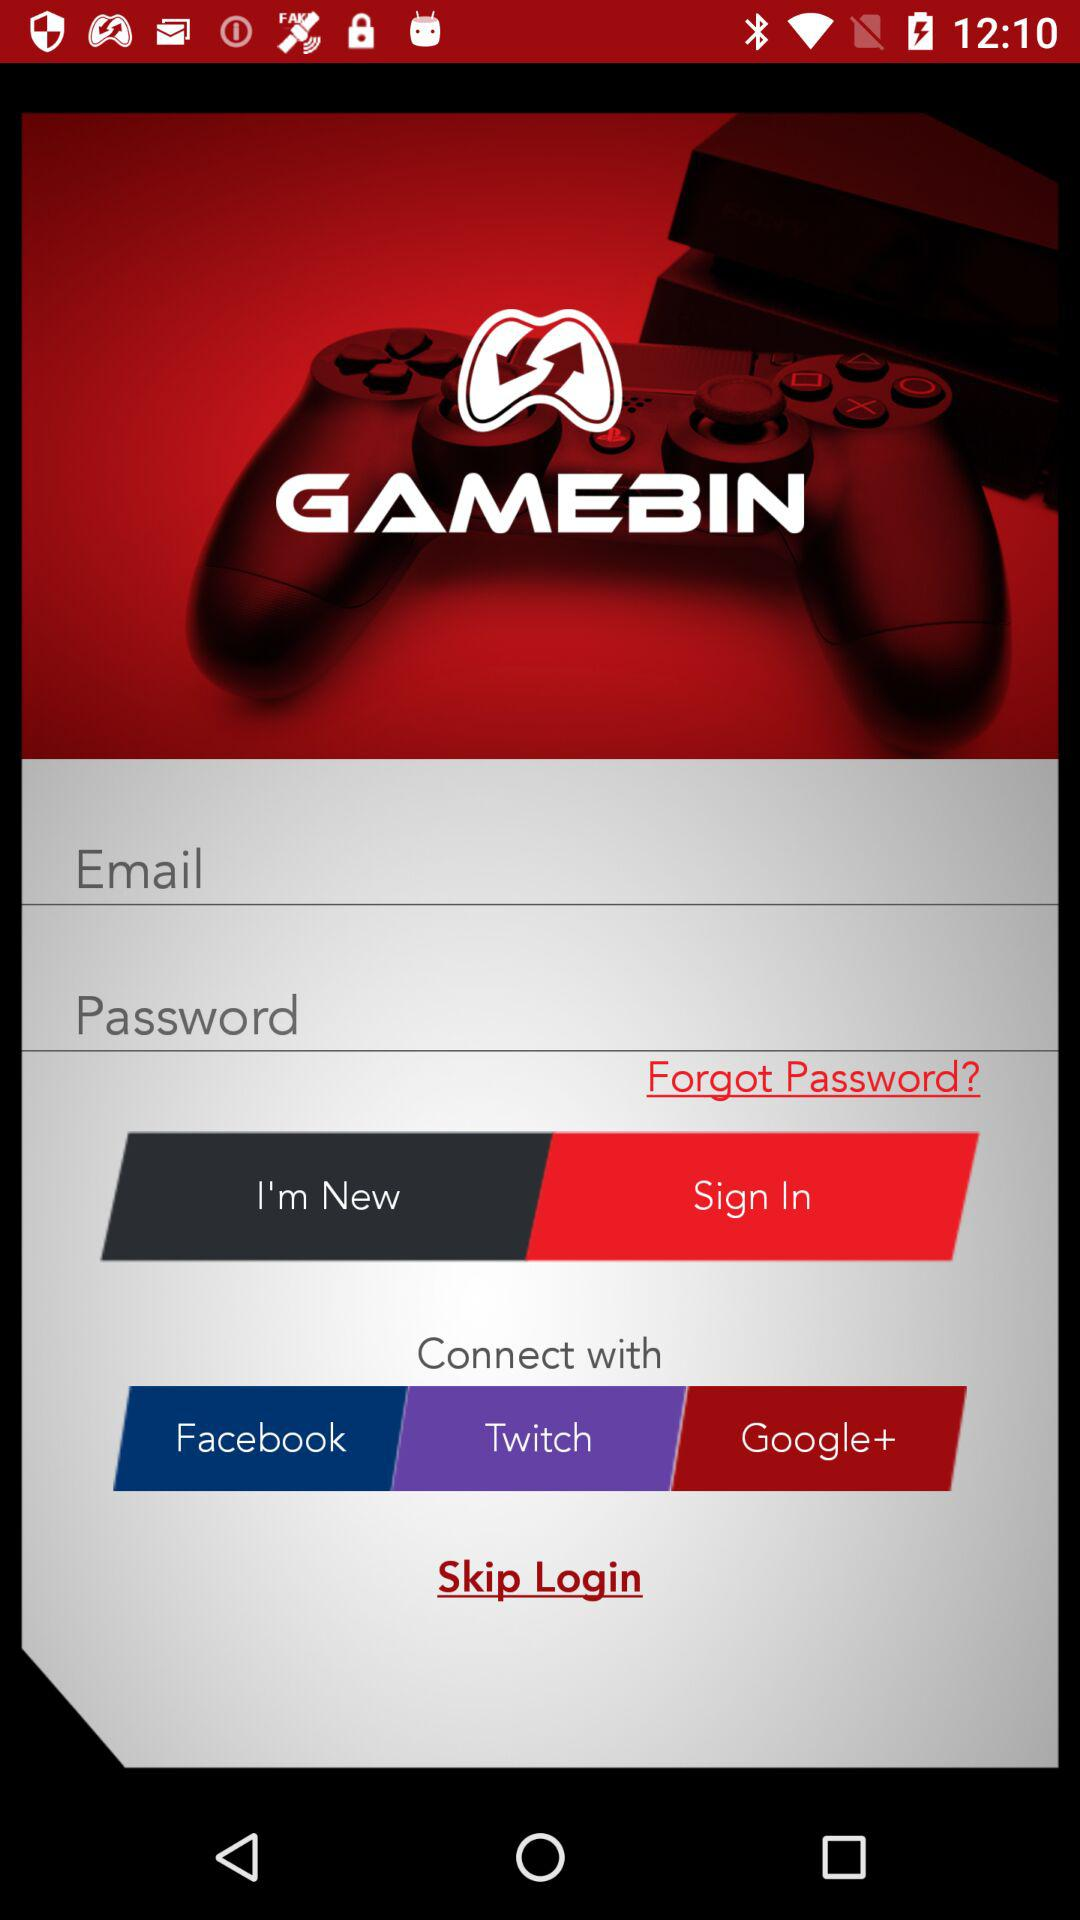Can we reset password?
When the provided information is insufficient, respond with <no answer>. <no answer> 